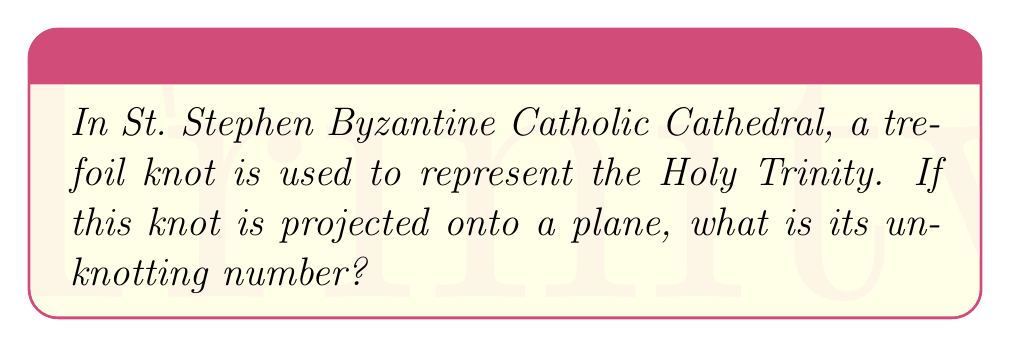Give your solution to this math problem. To calculate the unknotting number of a trefoil knot, we need to follow these steps:

1. Understand the definition: The unknotting number is the minimum number of times we need to pass one strand through another to turn the knot into an unknot (simple loop).

2. Recognize the trefoil knot: The trefoil knot is the simplest non-trivial knot, represented by the following diagram:

[asy]
import graph;
size(100);
path p = (0,0){right}..{up}(1,1){up}..{left}(0,2){left}..{down}(-1,1){down}..{right}cycle;
draw(p);
draw(p shifted(0.1Z), white);
[/asy]

3. Analyze the crossings: The trefoil knot has three crossings in its standard projection.

4. Consider the unknotting process: To unknot the trefoil, we need to change at least one of these crossings.

5. Determine the minimum changes: It can be proven that changing just one crossing is not sufficient to unknot the trefoil. However, changing any two of the three crossings will result in an unknot.

6. Conclude: The unknotting number of a trefoil knot is 1, as we need to perform one crossing change to transform it into an unknot.

This process reflects the complexity and unity of the Holy Trinity, where each "crossing" represents a distinct Person of the Trinity, yet they are inseparably One.
Answer: 1 